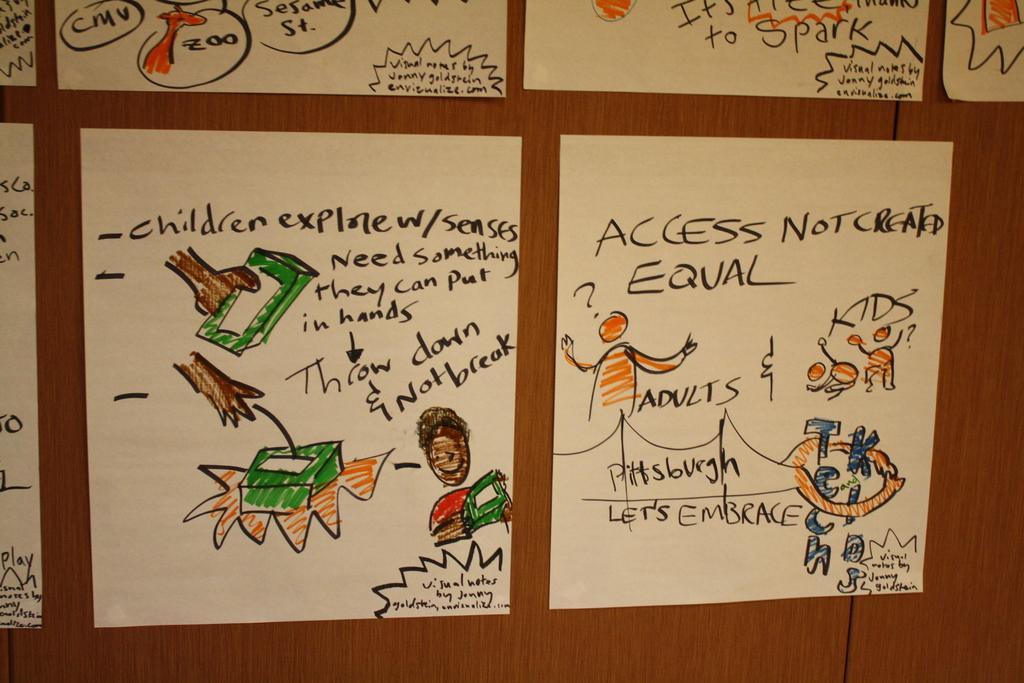Could you give a brief overview of what you see in this image? There are posters on which, there are texts and drawings. These posters are pasted on the wooden board. And the background is brown in color. 